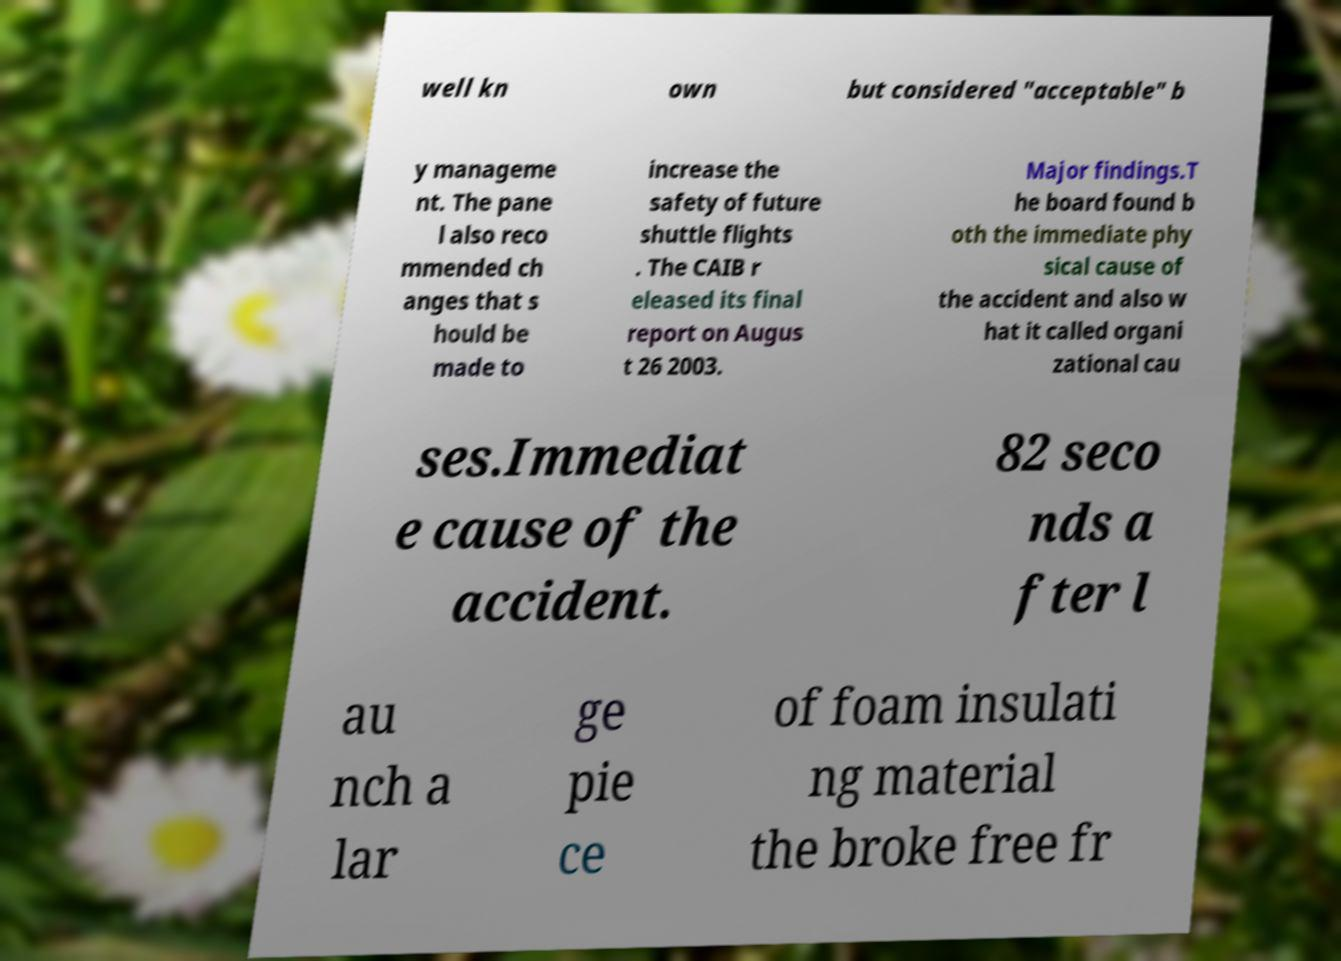Could you assist in decoding the text presented in this image and type it out clearly? well kn own but considered "acceptable" b y manageme nt. The pane l also reco mmended ch anges that s hould be made to increase the safety of future shuttle flights . The CAIB r eleased its final report on Augus t 26 2003. Major findings.T he board found b oth the immediate phy sical cause of the accident and also w hat it called organi zational cau ses.Immediat e cause of the accident. 82 seco nds a fter l au nch a lar ge pie ce of foam insulati ng material the broke free fr 